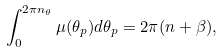Convert formula to latex. <formula><loc_0><loc_0><loc_500><loc_500>\int _ { 0 } ^ { 2 \pi n _ { \theta } } \mu ( \theta _ { p } ) d \theta _ { p } = 2 \pi ( n + \beta ) ,</formula> 